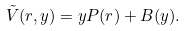Convert formula to latex. <formula><loc_0><loc_0><loc_500><loc_500>\tilde { V } ( r , y ) = y P ( r ) + B ( y ) .</formula> 